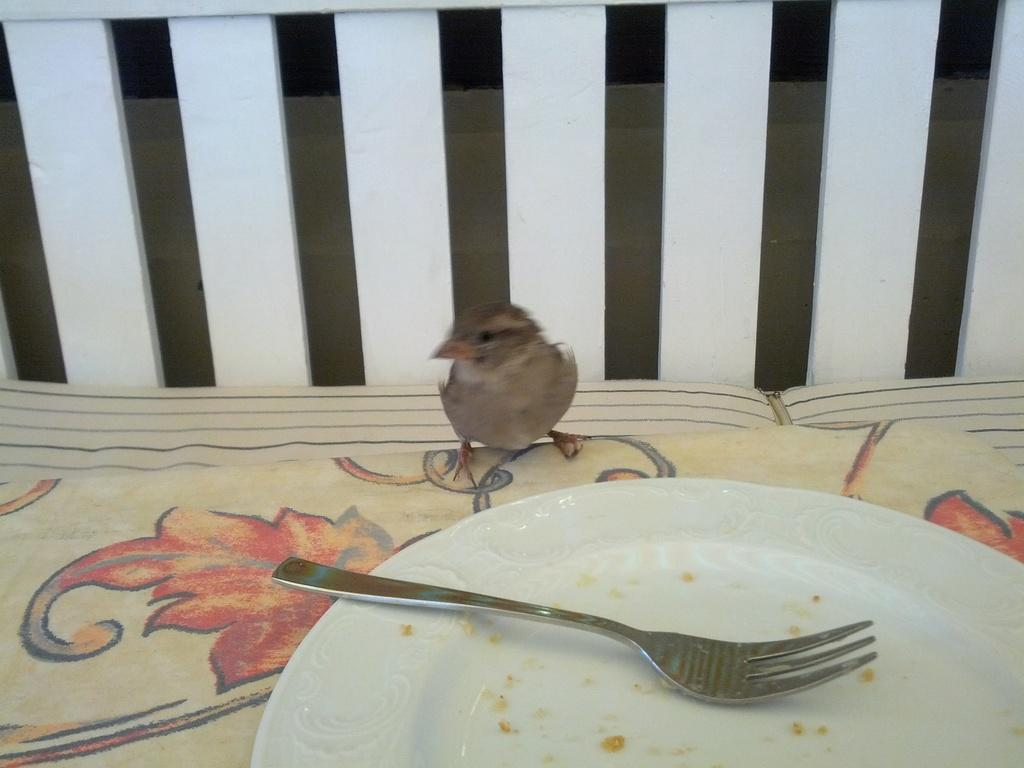What is on the plate in the image? There is an empty plate in the image, and a fork is on the plate. What is in front of the plate? There is a small bird in front of the plate. What can be seen behind the bird? There are white wooden sticks behind the bird. How many cards are being balanced by the bird in the image? There are no cards present in the image; it features a small bird, an empty plate, a fork, and white wooden sticks. Is there any salt visible in the image? There is no salt visible in the image. 